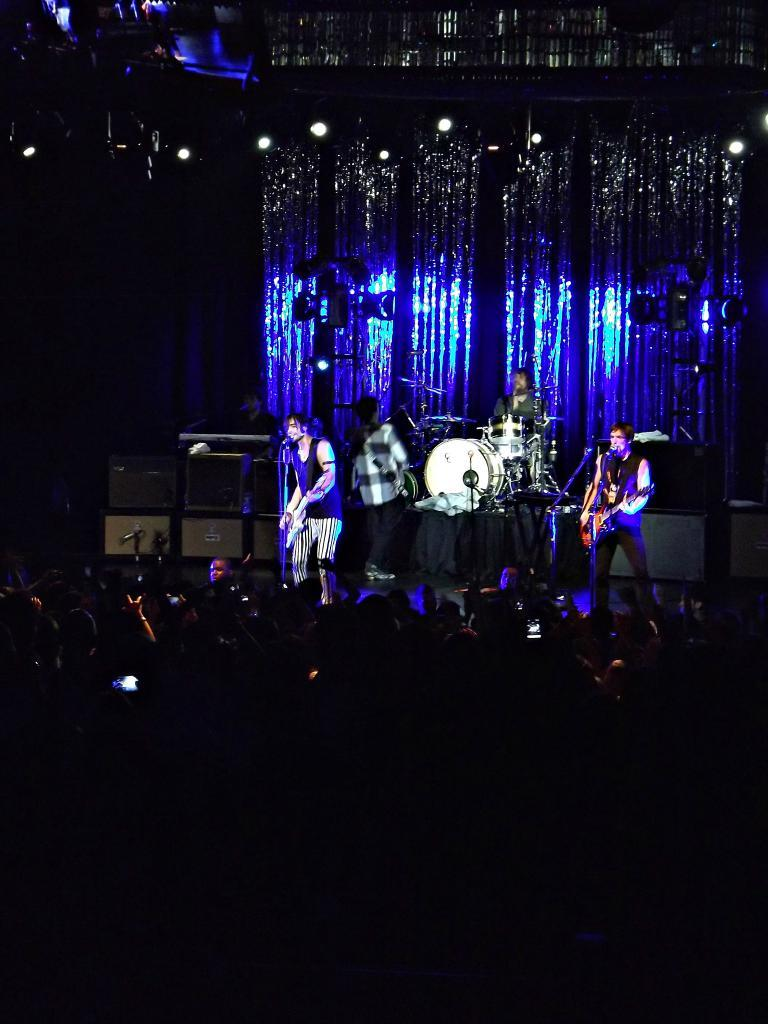What is the main subject of the image? The main subject of the image is a group of people. What objects are associated with the group of people? There are drums and speakers in the image. What are the people on-stage doing? The people on-stage are holding musical instruments. What type of lighting is present in the image? Focus lights are present in the image. What type of nerve can be seen in the image? There is no nerve present in the image; it features a group of people with musical instruments, drums, speakers, and focus lights. 